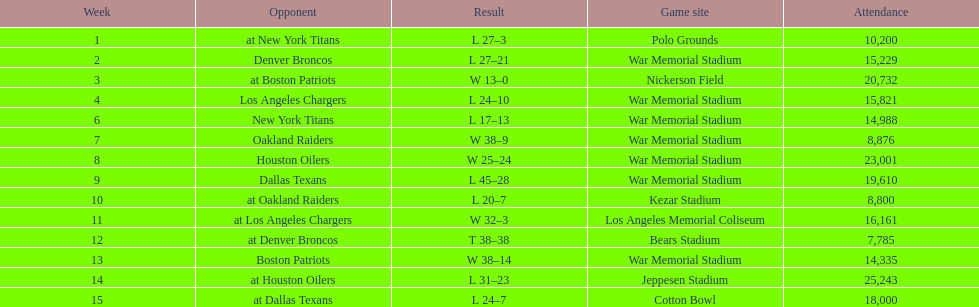How many games had at least 10,000 people in attendance? 11. 